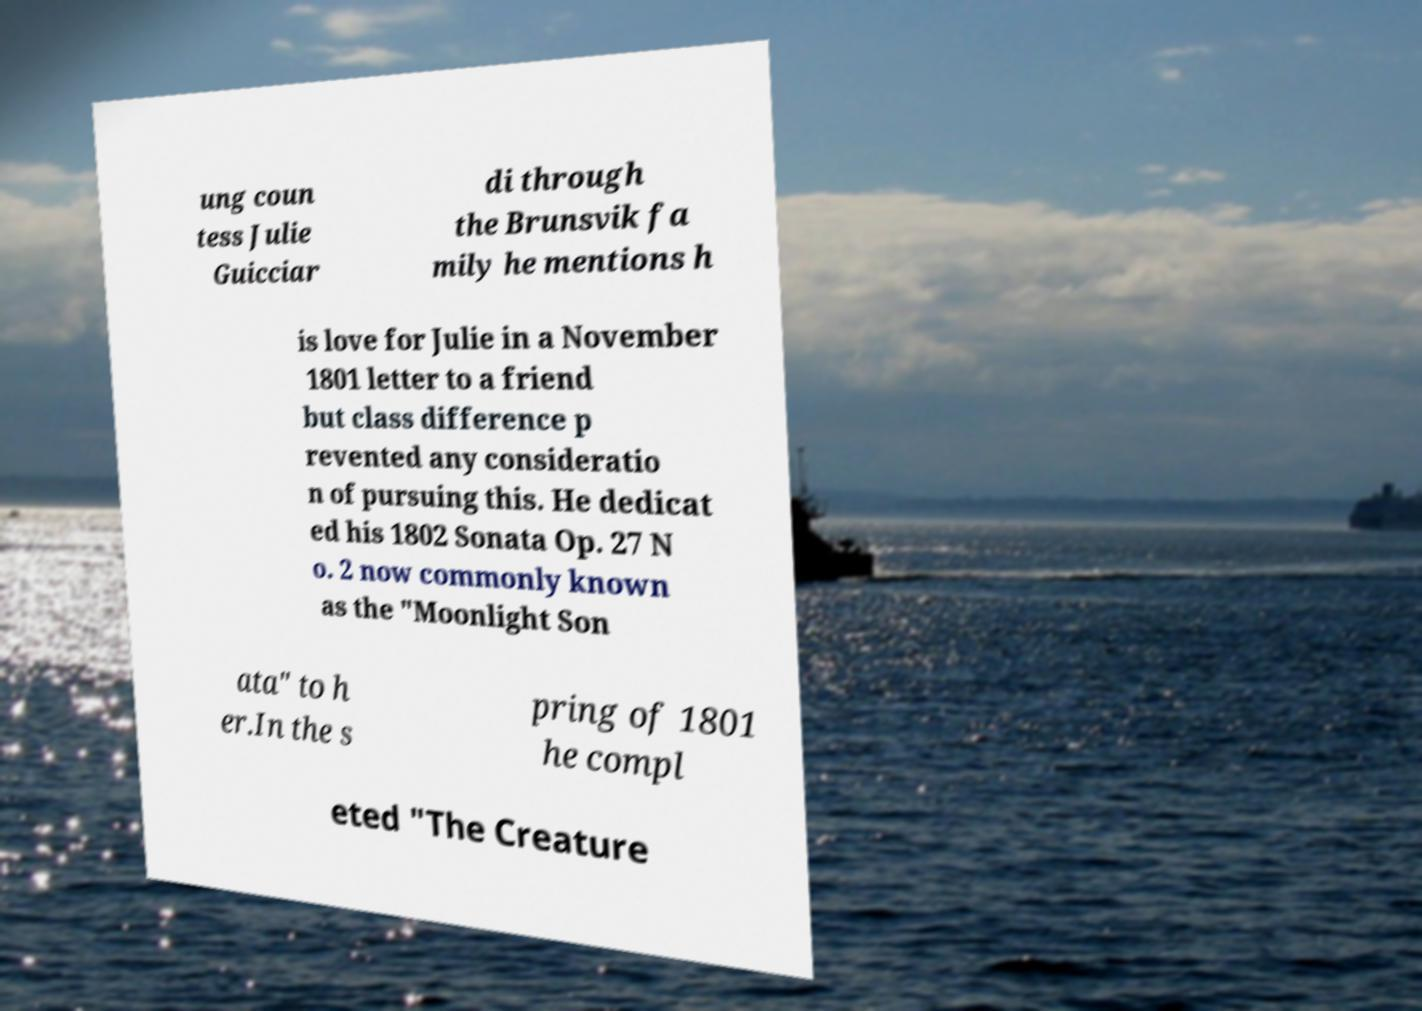Could you extract and type out the text from this image? ung coun tess Julie Guicciar di through the Brunsvik fa mily he mentions h is love for Julie in a November 1801 letter to a friend but class difference p revented any consideratio n of pursuing this. He dedicat ed his 1802 Sonata Op. 27 N o. 2 now commonly known as the "Moonlight Son ata" to h er.In the s pring of 1801 he compl eted "The Creature 